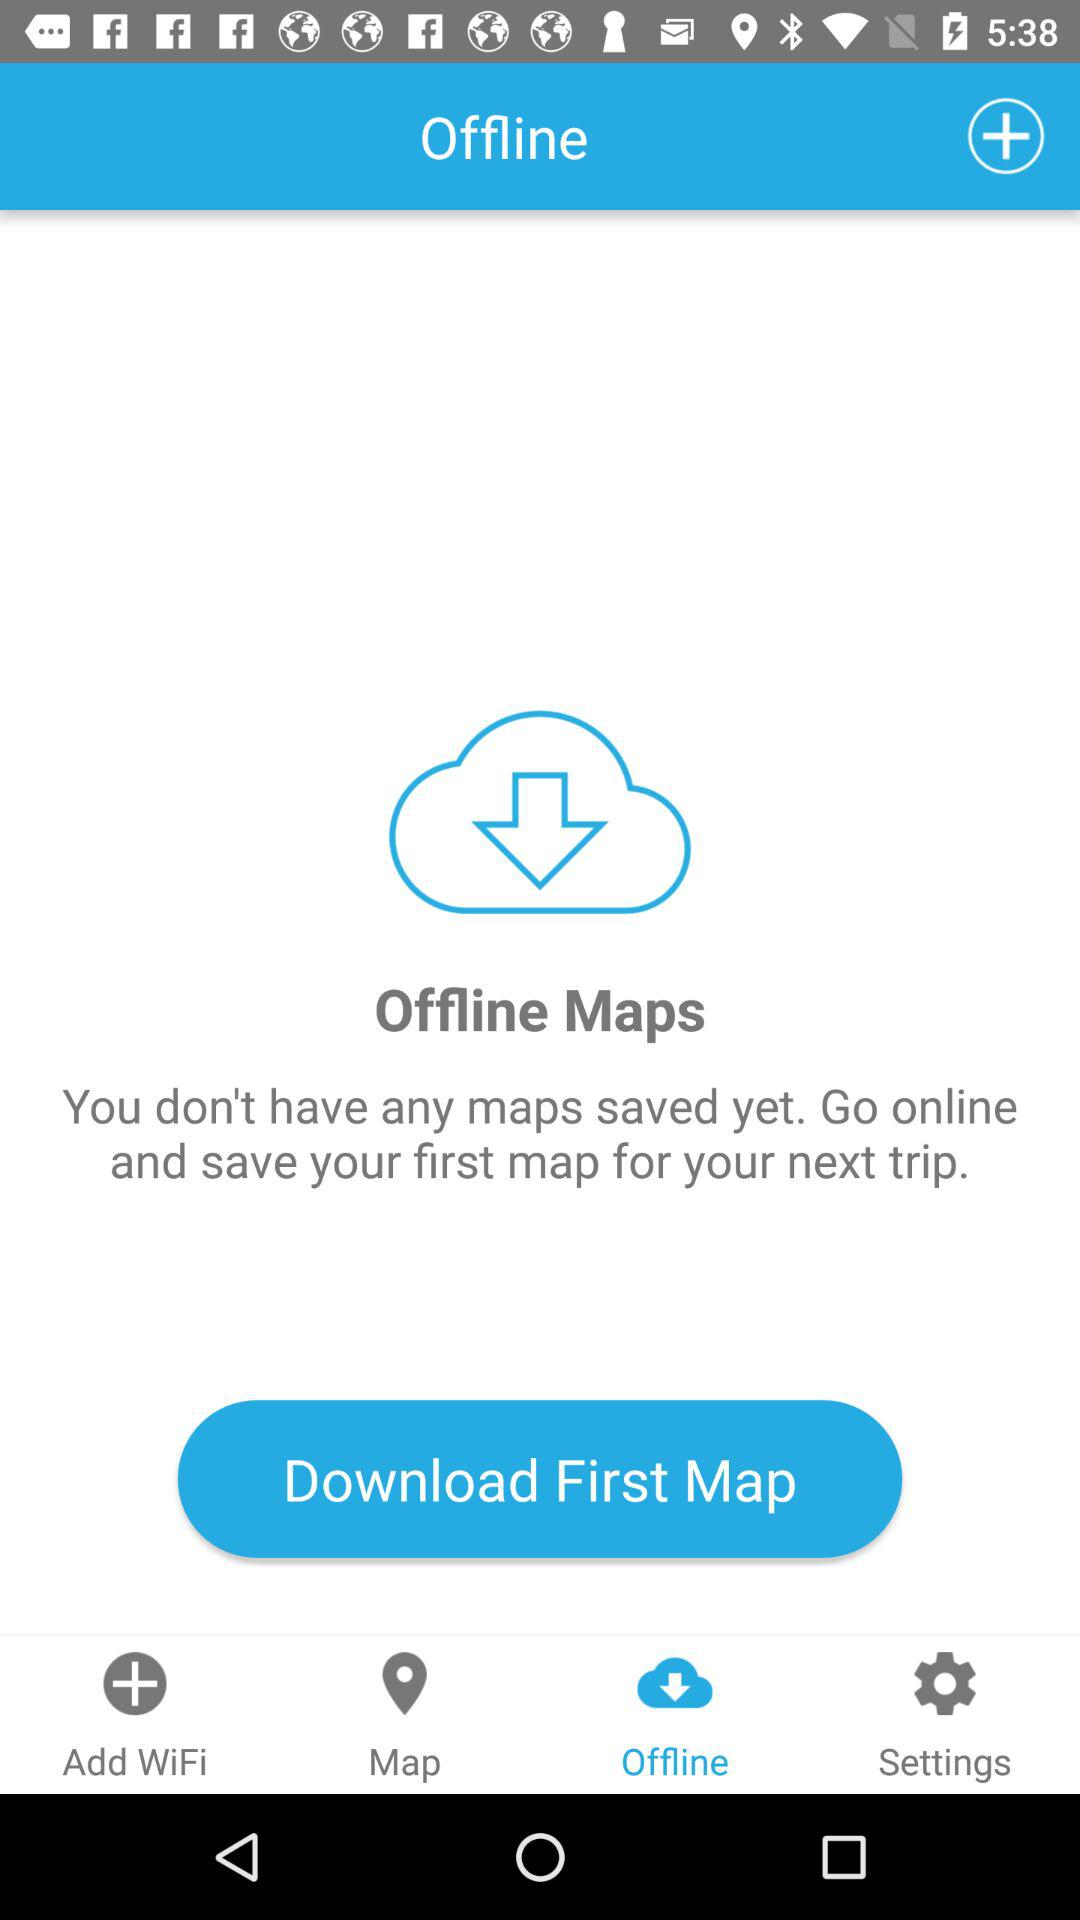How many offline maps do I have?
Answer the question using a single word or phrase. 0 